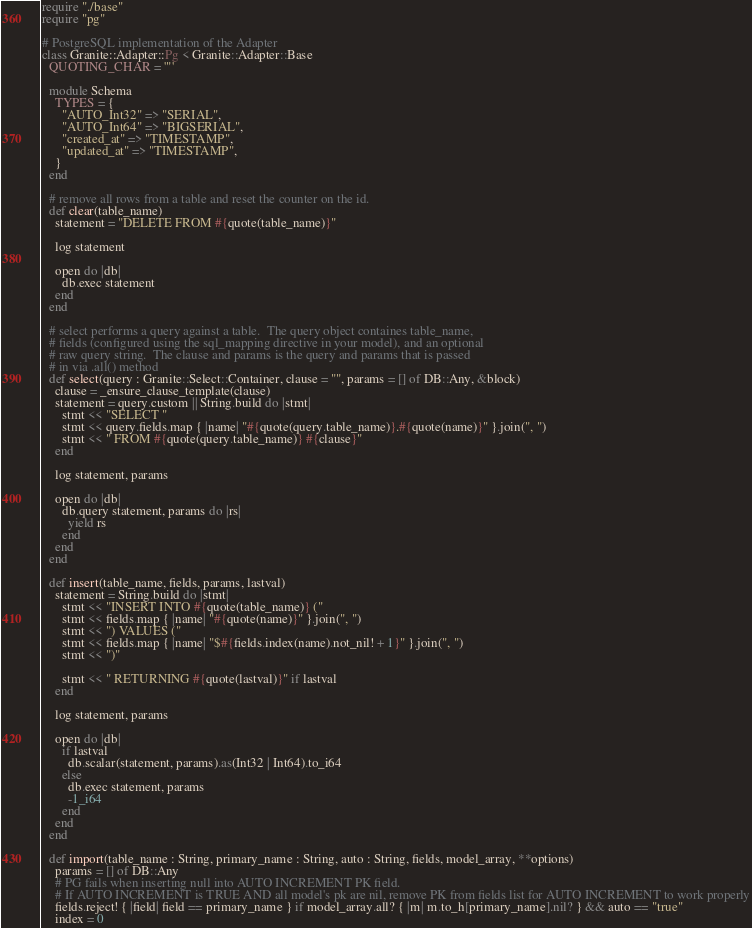Convert code to text. <code><loc_0><loc_0><loc_500><loc_500><_Crystal_>require "./base"
require "pg"

# PostgreSQL implementation of the Adapter
class Granite::Adapter::Pg < Granite::Adapter::Base
  QUOTING_CHAR = '"'

  module Schema
    TYPES = {
      "AUTO_Int32" => "SERIAL",
      "AUTO_Int64" => "BIGSERIAL",
      "created_at" => "TIMESTAMP",
      "updated_at" => "TIMESTAMP",
    }
  end

  # remove all rows from a table and reset the counter on the id.
  def clear(table_name)
    statement = "DELETE FROM #{quote(table_name)}"

    log statement

    open do |db|
      db.exec statement
    end
  end

  # select performs a query against a table.  The query object containes table_name,
  # fields (configured using the sql_mapping directive in your model), and an optional
  # raw query string.  The clause and params is the query and params that is passed
  # in via .all() method
  def select(query : Granite::Select::Container, clause = "", params = [] of DB::Any, &block)
    clause = _ensure_clause_template(clause)
    statement = query.custom || String.build do |stmt|
      stmt << "SELECT "
      stmt << query.fields.map { |name| "#{quote(query.table_name)}.#{quote(name)}" }.join(", ")
      stmt << " FROM #{quote(query.table_name)} #{clause}"
    end

    log statement, params

    open do |db|
      db.query statement, params do |rs|
        yield rs
      end
    end
  end

  def insert(table_name, fields, params, lastval)
    statement = String.build do |stmt|
      stmt << "INSERT INTO #{quote(table_name)} ("
      stmt << fields.map { |name| "#{quote(name)}" }.join(", ")
      stmt << ") VALUES ("
      stmt << fields.map { |name| "$#{fields.index(name).not_nil! + 1}" }.join(", ")
      stmt << ")"

      stmt << " RETURNING #{quote(lastval)}" if lastval
    end

    log statement, params

    open do |db|
      if lastval
        db.scalar(statement, params).as(Int32 | Int64).to_i64
      else
        db.exec statement, params
        -1_i64
      end
    end
  end

  def import(table_name : String, primary_name : String, auto : String, fields, model_array, **options)
    params = [] of DB::Any
    # PG fails when inserting null into AUTO INCREMENT PK field.
    # If AUTO INCREMENT is TRUE AND all model's pk are nil, remove PK from fields list for AUTO INCREMENT to work properly
    fields.reject! { |field| field == primary_name } if model_array.all? { |m| m.to_h[primary_name].nil? } && auto == "true"
    index = 0
</code> 